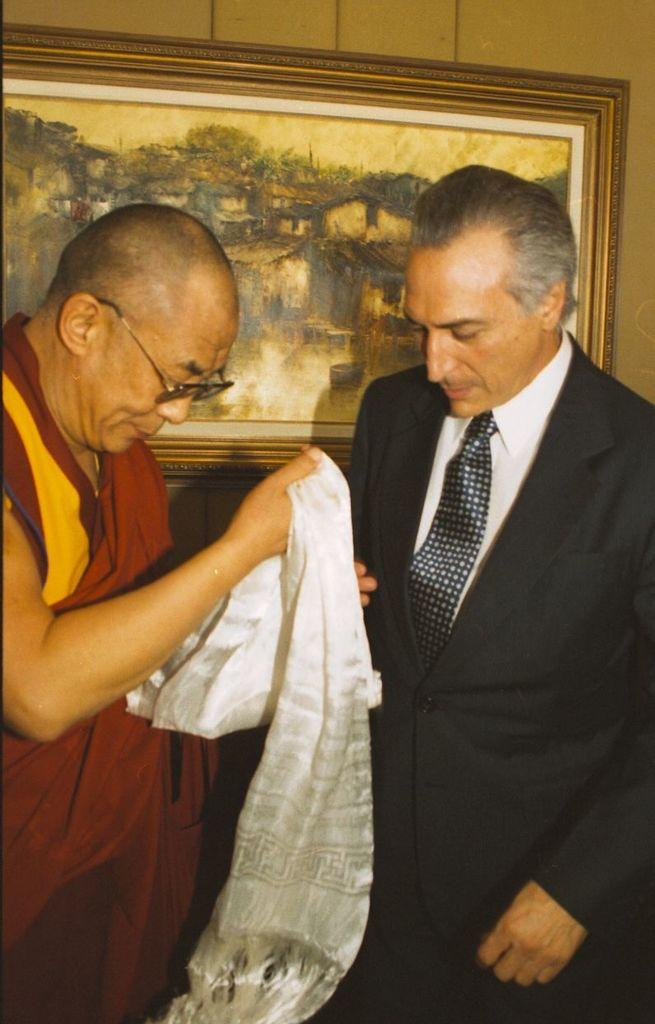How many people are present in the image? There are two persons in the image. What object can be seen in the image besides the people? There is a photo frame in the image. What type of background is visible in the image? There is a wall in the image. What is one person holding in their hand? One person is holding a cloth in their hand. Can you describe the possible setting of the image? The image may have been taken in a hall. What type of quilt is being used to draw on the wall in the image? There is no quilt or drawing on the wall in the image; it only shows two people and a photo frame. What color is the pencil being used by the person to write on the nation in the image? There is no pencil or writing on a nation in the image; it only shows two people, a photo frame, and a wall. 